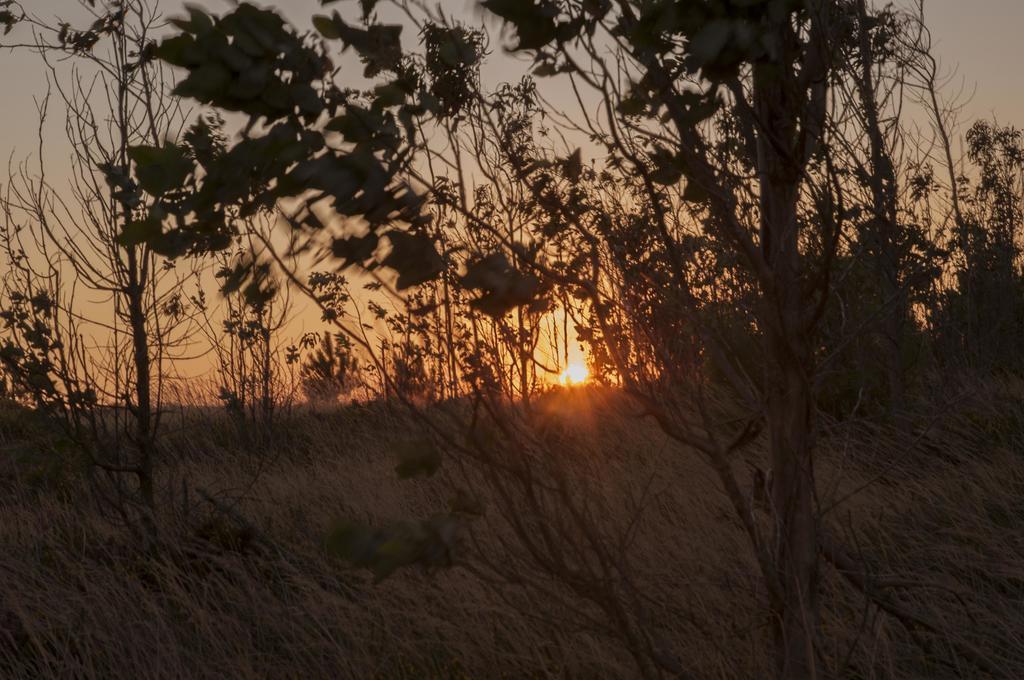Please provide a concise description of this image. This is an outside view. In the foreground, I can see some plants. In the background. I can see the sky along with the sun. 